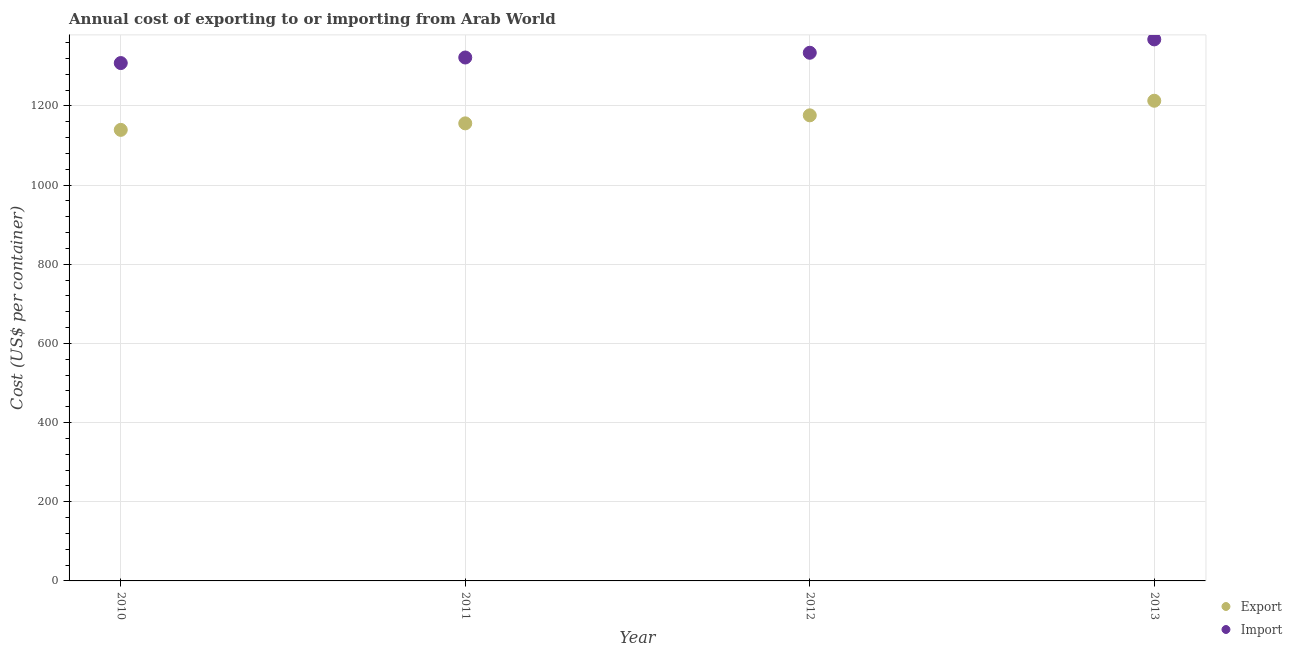How many different coloured dotlines are there?
Offer a terse response. 2. What is the import cost in 2013?
Your answer should be very brief. 1368.19. Across all years, what is the maximum export cost?
Give a very brief answer. 1213.19. Across all years, what is the minimum import cost?
Your answer should be very brief. 1308.4. In which year was the import cost maximum?
Provide a succinct answer. 2013. What is the total export cost in the graph?
Provide a short and direct response. 4685.17. What is the difference between the import cost in 2010 and that in 2011?
Your answer should be compact. -14.05. What is the difference between the export cost in 2010 and the import cost in 2013?
Make the answer very short. -228.59. What is the average export cost per year?
Your answer should be compact. 1171.29. In the year 2013, what is the difference between the import cost and export cost?
Offer a very short reply. 155. What is the ratio of the export cost in 2010 to that in 2012?
Your answer should be compact. 0.97. What is the difference between the highest and the second highest import cost?
Make the answer very short. 33.76. What is the difference between the highest and the lowest import cost?
Your response must be concise. 59.79. Is the sum of the import cost in 2010 and 2012 greater than the maximum export cost across all years?
Your answer should be very brief. Yes. Are the values on the major ticks of Y-axis written in scientific E-notation?
Offer a terse response. No. Does the graph contain grids?
Provide a short and direct response. Yes. How are the legend labels stacked?
Keep it short and to the point. Vertical. What is the title of the graph?
Provide a short and direct response. Annual cost of exporting to or importing from Arab World. What is the label or title of the X-axis?
Offer a terse response. Year. What is the label or title of the Y-axis?
Your answer should be very brief. Cost (US$ per container). What is the Cost (US$ per container) in Export in 2010?
Offer a terse response. 1139.6. What is the Cost (US$ per container) of Import in 2010?
Your answer should be very brief. 1308.4. What is the Cost (US$ per container) of Export in 2011?
Provide a succinct answer. 1156.05. What is the Cost (US$ per container) of Import in 2011?
Offer a very short reply. 1322.45. What is the Cost (US$ per container) in Export in 2012?
Offer a terse response. 1176.33. What is the Cost (US$ per container) of Import in 2012?
Provide a short and direct response. 1334.43. What is the Cost (US$ per container) of Export in 2013?
Offer a very short reply. 1213.19. What is the Cost (US$ per container) of Import in 2013?
Provide a short and direct response. 1368.19. Across all years, what is the maximum Cost (US$ per container) of Export?
Make the answer very short. 1213.19. Across all years, what is the maximum Cost (US$ per container) in Import?
Provide a succinct answer. 1368.19. Across all years, what is the minimum Cost (US$ per container) in Export?
Your response must be concise. 1139.6. Across all years, what is the minimum Cost (US$ per container) in Import?
Give a very brief answer. 1308.4. What is the total Cost (US$ per container) of Export in the graph?
Keep it short and to the point. 4685.17. What is the total Cost (US$ per container) in Import in the graph?
Offer a terse response. 5333.47. What is the difference between the Cost (US$ per container) of Export in 2010 and that in 2011?
Your answer should be very brief. -16.45. What is the difference between the Cost (US$ per container) in Import in 2010 and that in 2011?
Offer a terse response. -14.05. What is the difference between the Cost (US$ per container) in Export in 2010 and that in 2012?
Provide a short and direct response. -36.73. What is the difference between the Cost (US$ per container) of Import in 2010 and that in 2012?
Your answer should be very brief. -26.03. What is the difference between the Cost (US$ per container) in Export in 2010 and that in 2013?
Offer a very short reply. -73.59. What is the difference between the Cost (US$ per container) in Import in 2010 and that in 2013?
Your response must be concise. -59.79. What is the difference between the Cost (US$ per container) in Export in 2011 and that in 2012?
Provide a short and direct response. -20.28. What is the difference between the Cost (US$ per container) in Import in 2011 and that in 2012?
Offer a terse response. -11.98. What is the difference between the Cost (US$ per container) in Export in 2011 and that in 2013?
Offer a very short reply. -57.14. What is the difference between the Cost (US$ per container) of Import in 2011 and that in 2013?
Give a very brief answer. -45.74. What is the difference between the Cost (US$ per container) in Export in 2012 and that in 2013?
Your response must be concise. -36.86. What is the difference between the Cost (US$ per container) of Import in 2012 and that in 2013?
Offer a very short reply. -33.76. What is the difference between the Cost (US$ per container) of Export in 2010 and the Cost (US$ per container) of Import in 2011?
Provide a short and direct response. -182.85. What is the difference between the Cost (US$ per container) in Export in 2010 and the Cost (US$ per container) in Import in 2012?
Keep it short and to the point. -194.83. What is the difference between the Cost (US$ per container) of Export in 2010 and the Cost (US$ per container) of Import in 2013?
Make the answer very short. -228.59. What is the difference between the Cost (US$ per container) of Export in 2011 and the Cost (US$ per container) of Import in 2012?
Ensure brevity in your answer.  -178.38. What is the difference between the Cost (US$ per container) in Export in 2011 and the Cost (US$ per container) in Import in 2013?
Your response must be concise. -212.14. What is the difference between the Cost (US$ per container) of Export in 2012 and the Cost (US$ per container) of Import in 2013?
Make the answer very short. -191.86. What is the average Cost (US$ per container) of Export per year?
Ensure brevity in your answer.  1171.29. What is the average Cost (US$ per container) of Import per year?
Offer a very short reply. 1333.37. In the year 2010, what is the difference between the Cost (US$ per container) in Export and Cost (US$ per container) in Import?
Your answer should be compact. -168.8. In the year 2011, what is the difference between the Cost (US$ per container) in Export and Cost (US$ per container) in Import?
Offer a very short reply. -166.4. In the year 2012, what is the difference between the Cost (US$ per container) in Export and Cost (US$ per container) in Import?
Ensure brevity in your answer.  -158.1. In the year 2013, what is the difference between the Cost (US$ per container) in Export and Cost (US$ per container) in Import?
Your answer should be very brief. -155. What is the ratio of the Cost (US$ per container) in Export in 2010 to that in 2011?
Your answer should be compact. 0.99. What is the ratio of the Cost (US$ per container) of Import in 2010 to that in 2011?
Your response must be concise. 0.99. What is the ratio of the Cost (US$ per container) in Export in 2010 to that in 2012?
Your answer should be compact. 0.97. What is the ratio of the Cost (US$ per container) of Import in 2010 to that in 2012?
Make the answer very short. 0.98. What is the ratio of the Cost (US$ per container) in Export in 2010 to that in 2013?
Offer a terse response. 0.94. What is the ratio of the Cost (US$ per container) of Import in 2010 to that in 2013?
Provide a short and direct response. 0.96. What is the ratio of the Cost (US$ per container) of Export in 2011 to that in 2012?
Keep it short and to the point. 0.98. What is the ratio of the Cost (US$ per container) of Import in 2011 to that in 2012?
Your answer should be compact. 0.99. What is the ratio of the Cost (US$ per container) in Export in 2011 to that in 2013?
Offer a very short reply. 0.95. What is the ratio of the Cost (US$ per container) in Import in 2011 to that in 2013?
Ensure brevity in your answer.  0.97. What is the ratio of the Cost (US$ per container) of Export in 2012 to that in 2013?
Keep it short and to the point. 0.97. What is the ratio of the Cost (US$ per container) in Import in 2012 to that in 2013?
Ensure brevity in your answer.  0.98. What is the difference between the highest and the second highest Cost (US$ per container) of Export?
Give a very brief answer. 36.86. What is the difference between the highest and the second highest Cost (US$ per container) of Import?
Your answer should be compact. 33.76. What is the difference between the highest and the lowest Cost (US$ per container) in Export?
Make the answer very short. 73.59. What is the difference between the highest and the lowest Cost (US$ per container) in Import?
Provide a succinct answer. 59.79. 